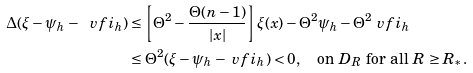<formula> <loc_0><loc_0><loc_500><loc_500>\Delta ( \xi - \psi _ { h } - \ v f i _ { h } ) & \leq \left [ \Theta ^ { 2 } - \frac { \Theta ( n - 1 ) } { | x | } \right ] \xi ( x ) - \Theta ^ { 2 } \psi _ { h } - \Theta ^ { 2 } \ v f i _ { h } \\ & \leq \Theta ^ { 2 } ( \xi - \psi _ { h } - \ v f i _ { h } ) < 0 , \quad \text {on $D_{R}$ for all $R\geq R_{*}$} .</formula> 